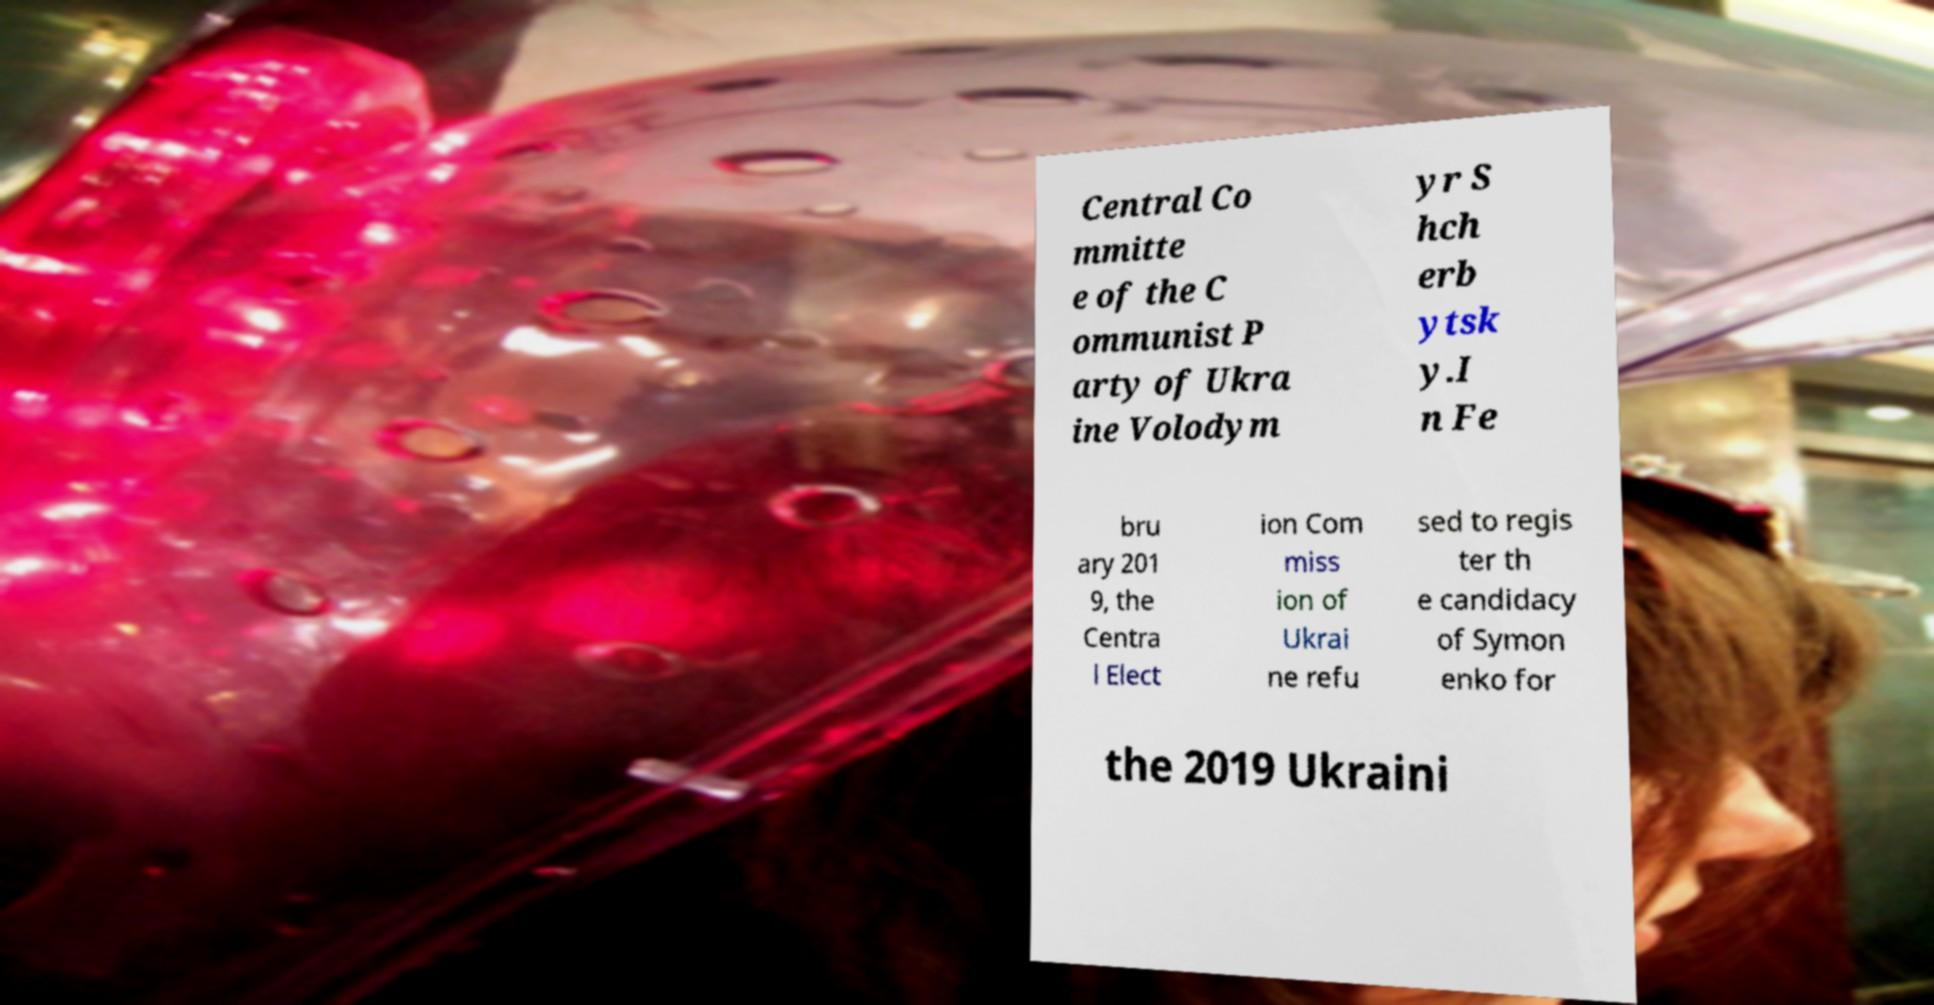Could you extract and type out the text from this image? Central Co mmitte e of the C ommunist P arty of Ukra ine Volodym yr S hch erb ytsk y.I n Fe bru ary 201 9, the Centra l Elect ion Com miss ion of Ukrai ne refu sed to regis ter th e candidacy of Symon enko for the 2019 Ukraini 